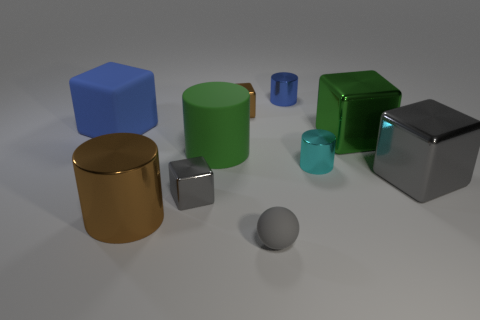Subtract all shiny cylinders. How many cylinders are left? 1 Subtract all gray cylinders. How many gray blocks are left? 2 Subtract all balls. How many objects are left? 9 Subtract all brown cylinders. How many cylinders are left? 3 Subtract 3 cylinders. How many cylinders are left? 1 Add 1 green things. How many green things are left? 3 Add 2 small brown objects. How many small brown objects exist? 3 Subtract 0 yellow spheres. How many objects are left? 10 Subtract all green cubes. Subtract all brown cylinders. How many cubes are left? 4 Subtract all gray cubes. Subtract all large brown metallic cylinders. How many objects are left? 7 